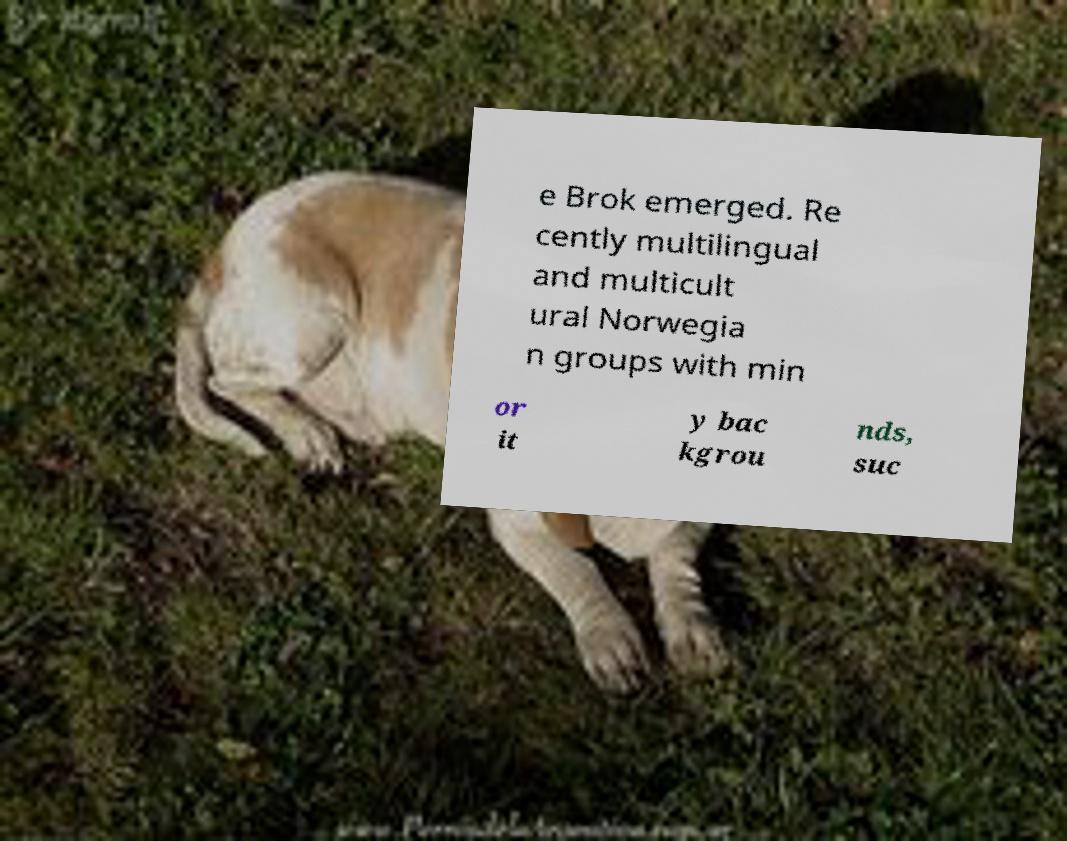Could you assist in decoding the text presented in this image and type it out clearly? e Brok emerged. Re cently multilingual and multicult ural Norwegia n groups with min or it y bac kgrou nds, suc 